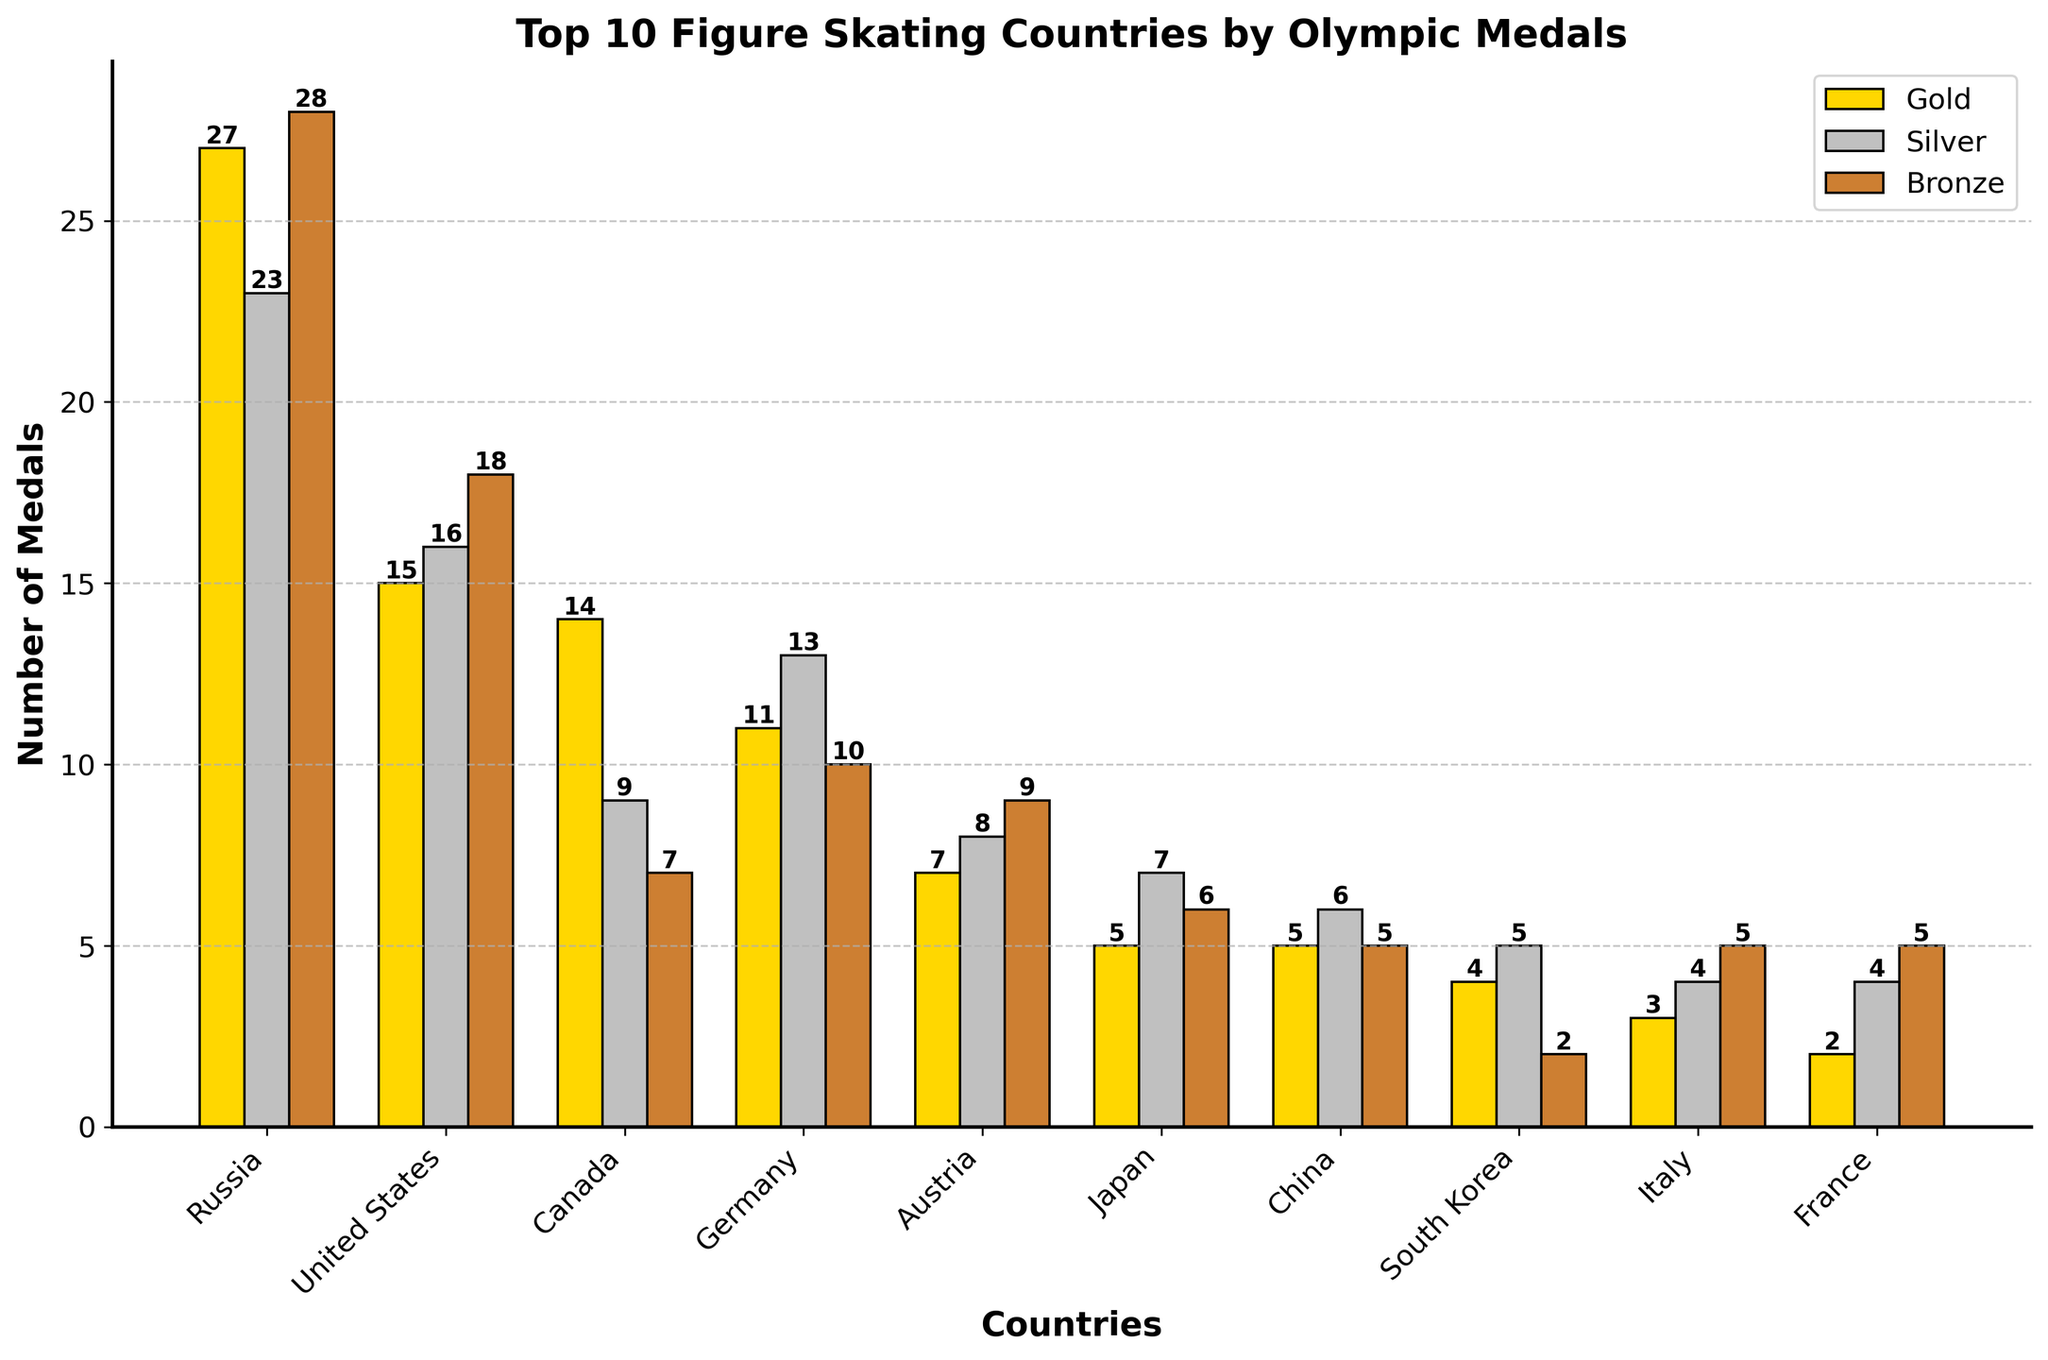What is the total number of gold medals won by Canada? The bar representing Canada for gold medals is labeled with the number 14.
Answer: 14 Which country has won the most silver medals? Looking at the heights and labels of the silver medal bars, Russia has the highest count with 23.
Answer: Russia How many more total medals has Germany won compared to Austria? The total number of medals won by Germany is 34, and Austria is 24. Subtracting these gives 34 - 24 = 10.
Answer: 10 What is the combined number of bronze medals won by Japan and South Korea? Japan has won 6 bronze medals and South Korea has 2 bronze medals. Adding these gives 6 + 2 = 8.
Answer: 8 Which country has the fewest gold medals, and how many is that? The country with the shortest bar for gold medals, labeled with the smallest number, is France with 2 golds.
Answer: France, 2 If you combine the silver and bronze medals won by the United States, how many would they have? United States has 16 silver and 18 bronze medals. Adding these gives 16 + 18 = 34.
Answer: 34 Which two countries have equal total medals, and what is the total? Both South Korea and France have a total of 11 medals each.
Answer: South Korea and France, 11 What is the difference in gold medals between Russia and the United States? Russia has 27 gold medals, and the United States has 15 gold medals. The difference is 27 - 15 = 12.
Answer: 12 How many medals in total have been won by the top three countries combined? Russia has 78 total medals, the United States has 49, and Canada has 30. Adding these together gives 78 + 49 + 30 = 157.
Answer: 157 Which country's bar is the tallest, and which medal type does it represent? The tallest bar in the chart is for Russia, representing gold medals.
Answer: Russia, Gold 